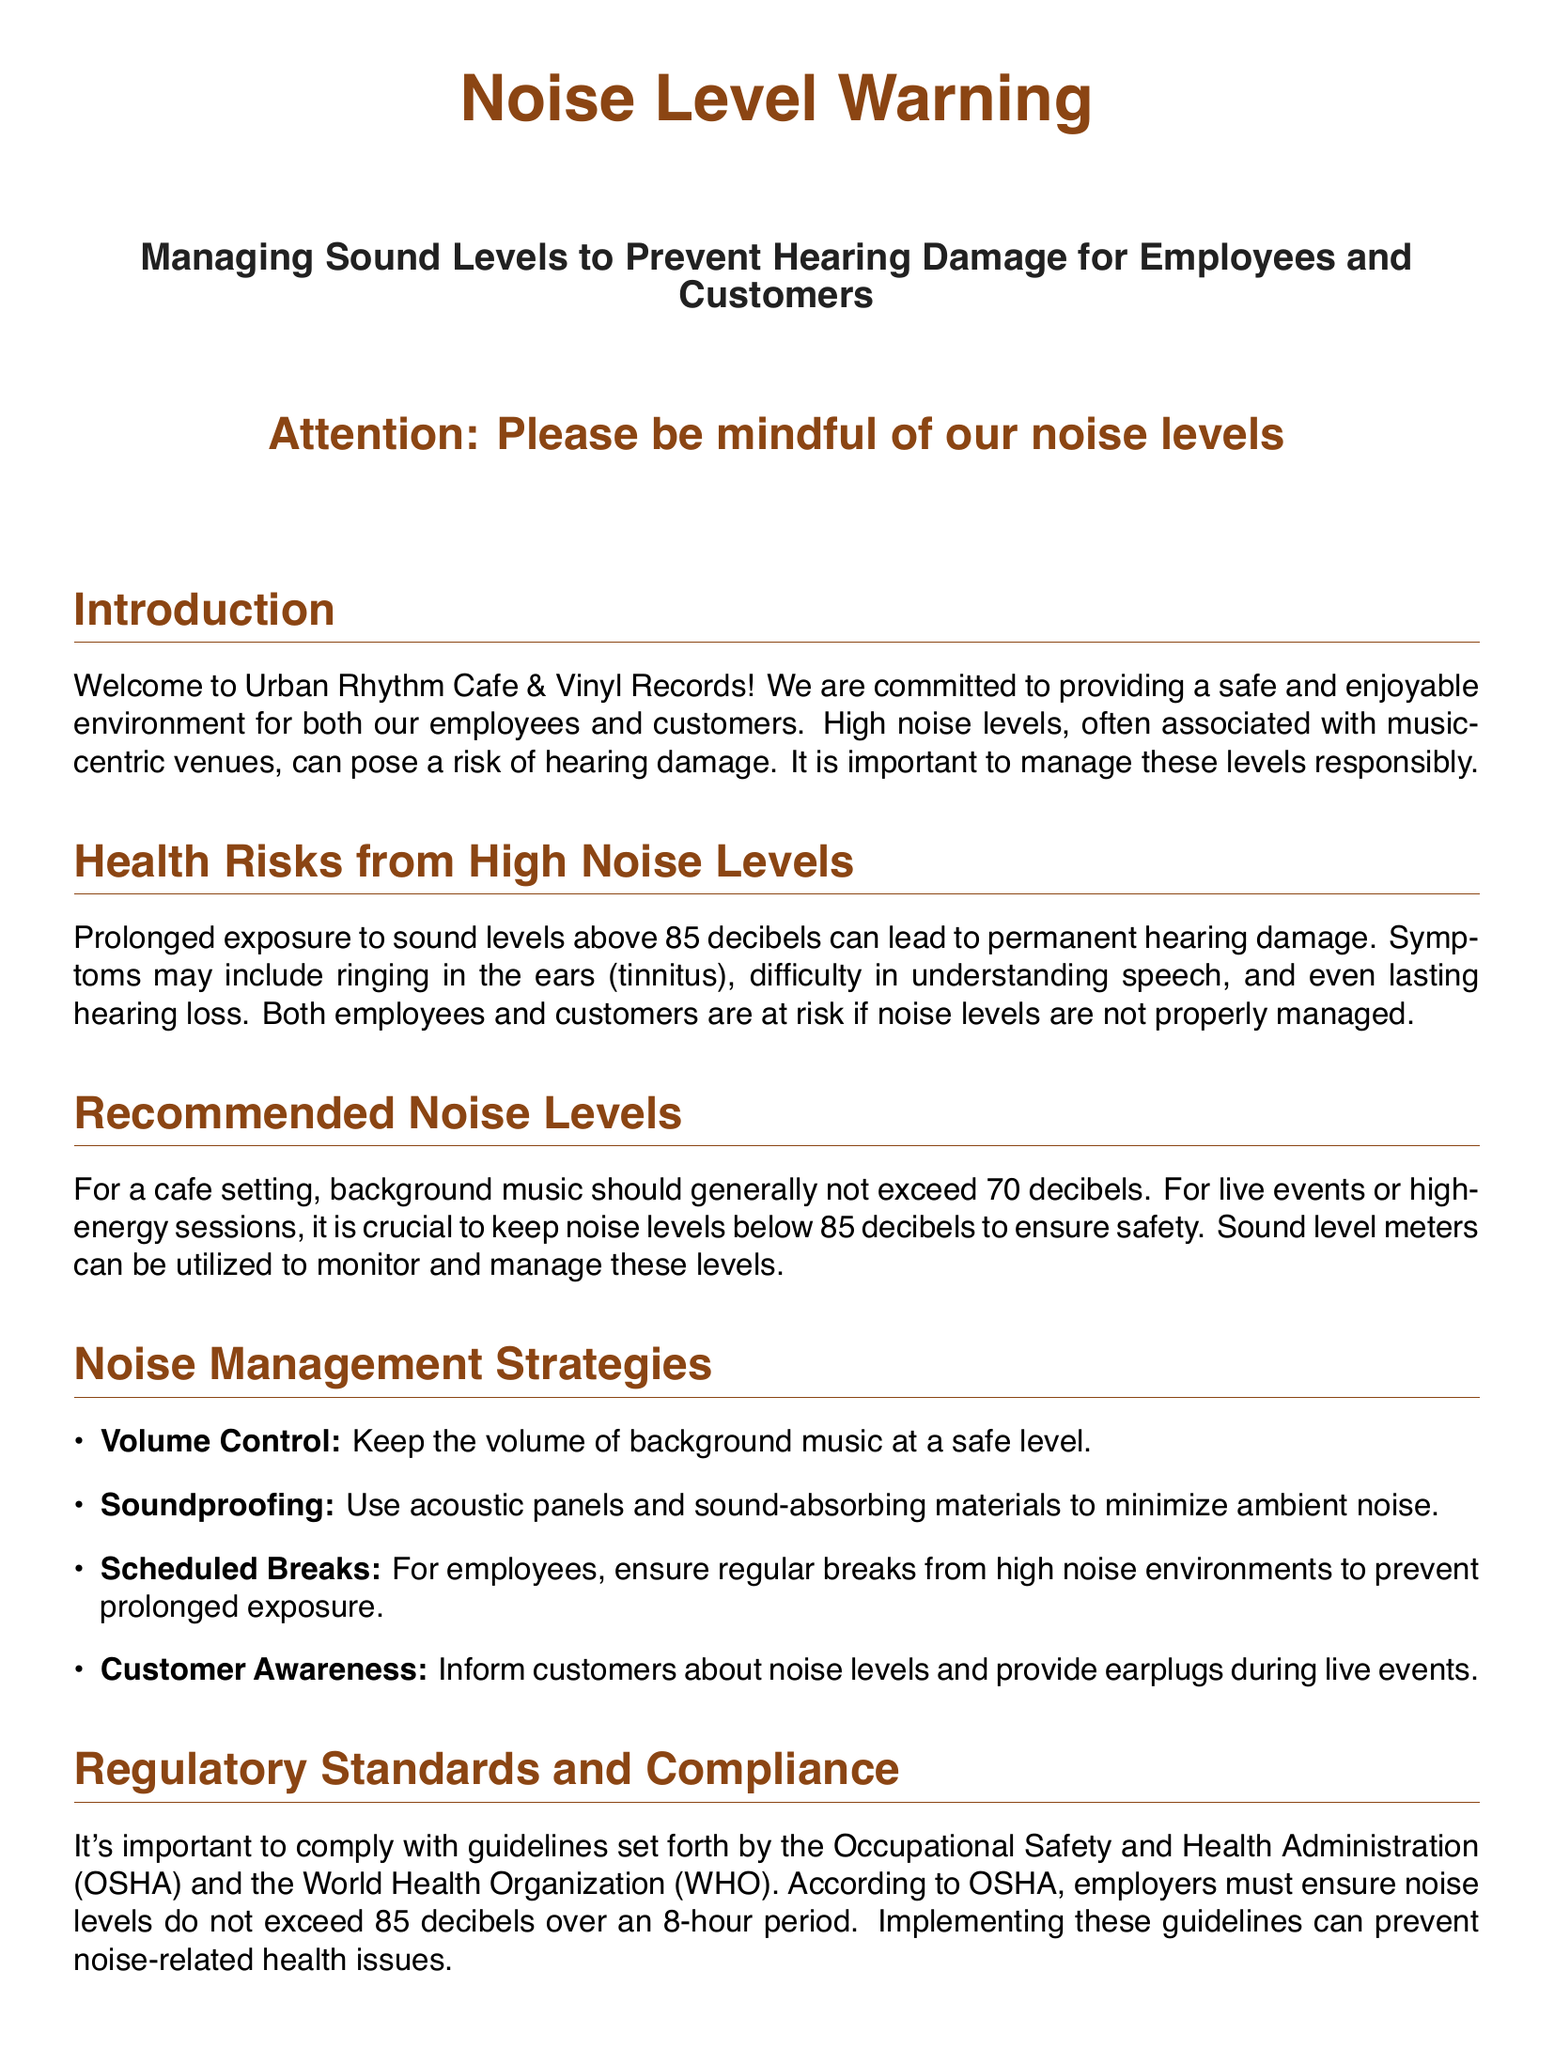What is the maximum recommended noise level for background music? The document states that background music should generally not exceed 70 decibels.
Answer: 70 decibels What are the health risks associated with high noise levels? The document mentions tinnitus, difficulty in understanding speech, and hearing loss as symptoms of high noise levels.
Answer: Tinnitus, difficulty in understanding speech, hearing loss What is the noise level threshold according to OSHA? OSHA guidelines specify that noise levels must not exceed 85 decibels over an 8-hour period.
Answer: 85 decibels What should be used to monitor noise levels? The document suggests utilizing sound level meters to monitor and manage noise levels.
Answer: Sound level meters What is one strategy to reduce ambient noise in the cafe? The document lists soundproofing with acoustic panels and sound-absorbing materials as a strategy.
Answer: Soundproofing How often should employees take breaks from high noise environments? The document mentions ensuring regular breaks for employees, but does not specify a frequency.
Answer: Regular breaks What should customers be informed about regarding noise levels? Customers should be informed about noise levels, and earplugs should be provided during live events.
Answer: Noise levels; earplugs Who should be contacted in case of a hearing-related emergency? The document provides local health services and the Occupational Safety and Health Administration as contact points.
Answer: Local Health Services, OSHA What is the main purpose of the document? The document aims to inform about managing sound levels to prevent hearing damage for employees and customers.
Answer: Managing sound levels to prevent hearing damage 